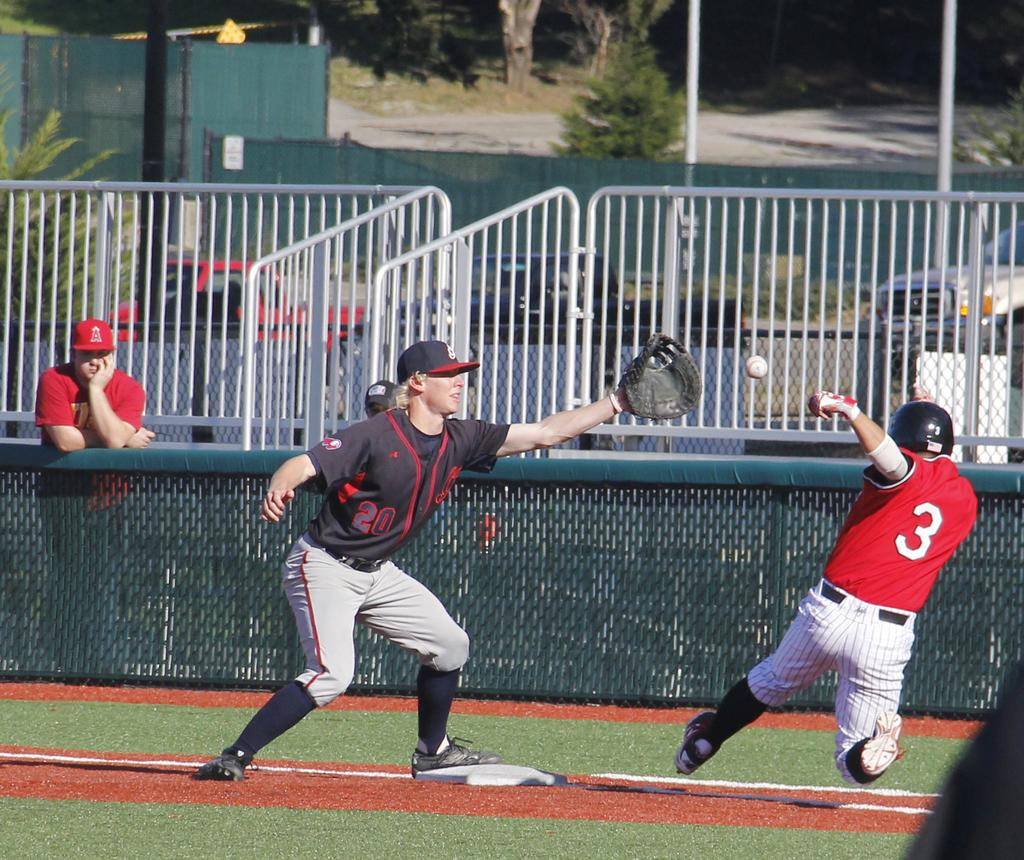<image>
Describe the image concisely. First baseman with no 20 is readying to catch the ball as the batter rushes the base. 